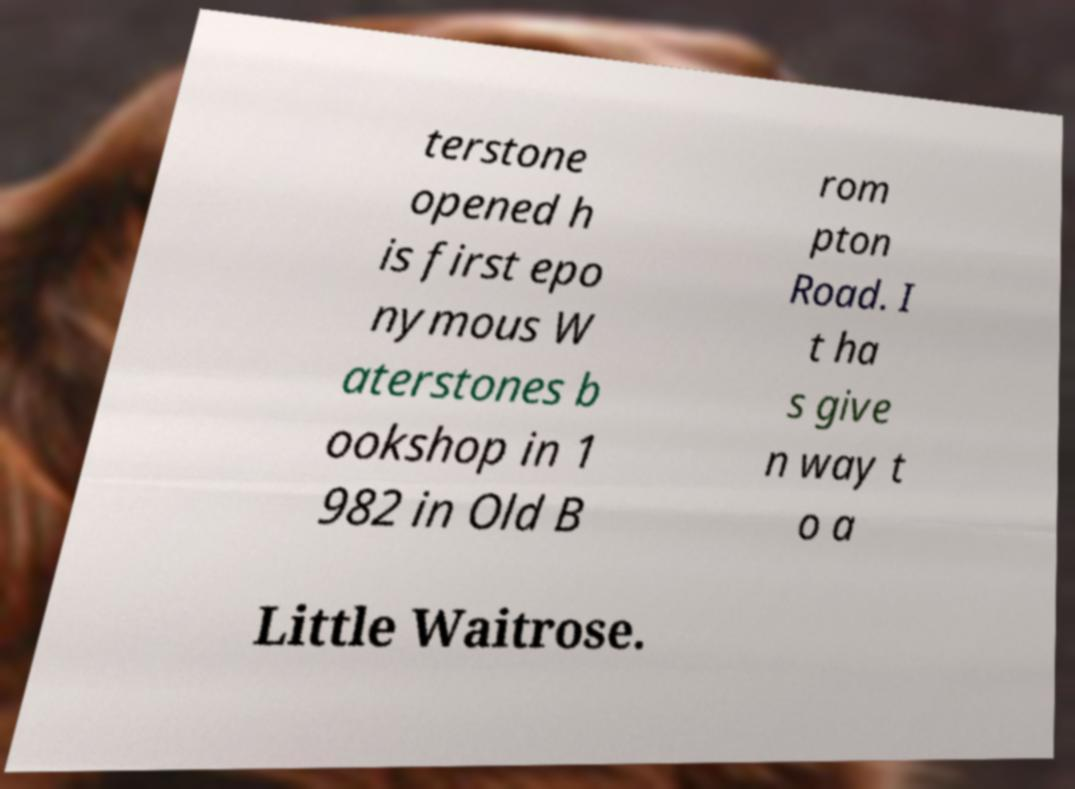Could you extract and type out the text from this image? terstone opened h is first epo nymous W aterstones b ookshop in 1 982 in Old B rom pton Road. I t ha s give n way t o a Little Waitrose. 